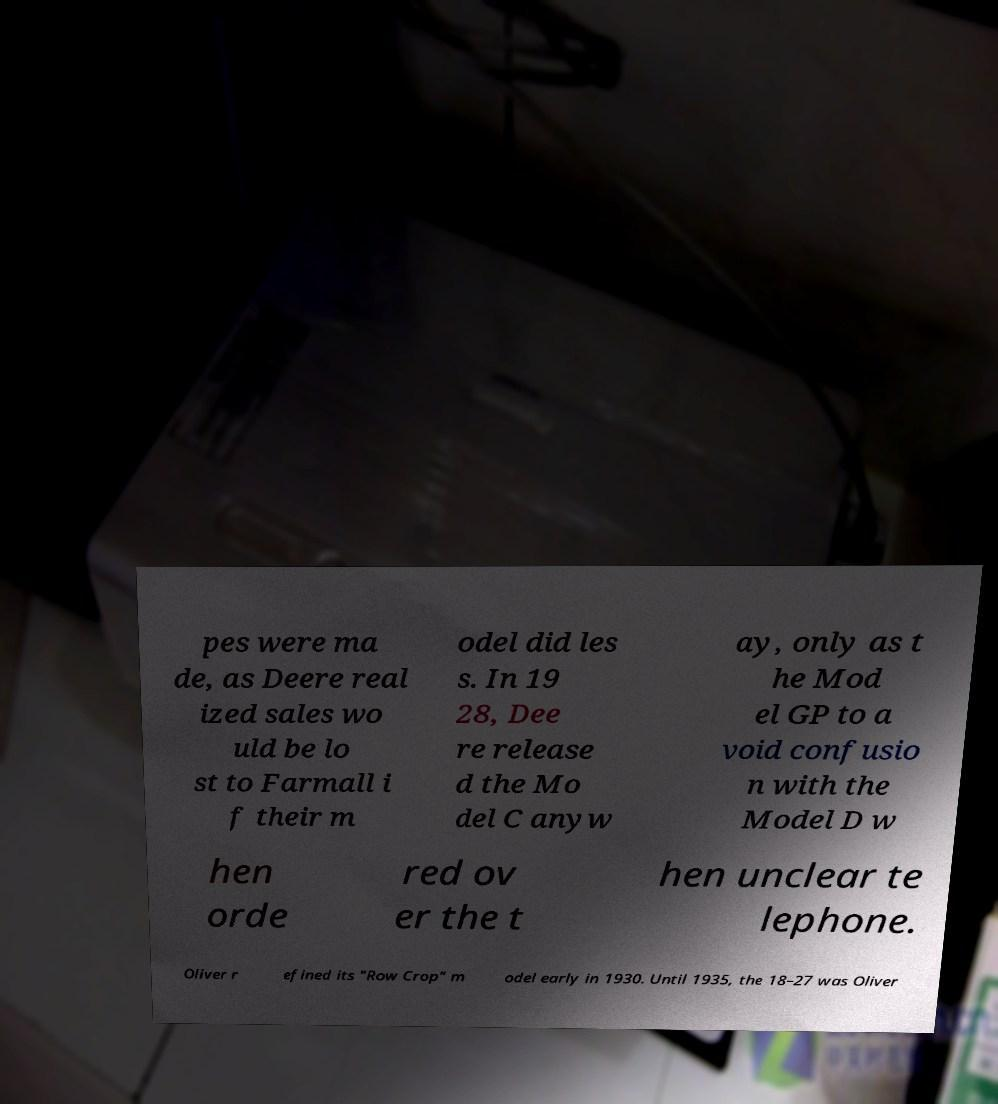Can you read and provide the text displayed in the image?This photo seems to have some interesting text. Can you extract and type it out for me? pes were ma de, as Deere real ized sales wo uld be lo st to Farmall i f their m odel did les s. In 19 28, Dee re release d the Mo del C anyw ay, only as t he Mod el GP to a void confusio n with the Model D w hen orde red ov er the t hen unclear te lephone. Oliver r efined its "Row Crop" m odel early in 1930. Until 1935, the 18–27 was Oliver 